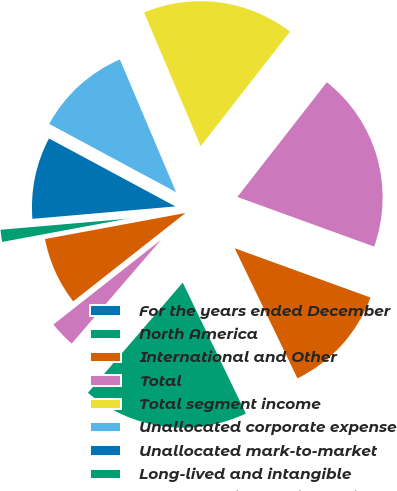<chart> <loc_0><loc_0><loc_500><loc_500><pie_chart><fcel>For the years ended December<fcel>North America<fcel>International and Other<fcel>Total<fcel>Total segment income<fcel>Unallocated corporate expense<fcel>Unallocated mark-to-market<fcel>Long-lived and intangible<fcel>Costs associated with business<fcel>Acquisition-related costs<nl><fcel>0.0%<fcel>18.46%<fcel>12.31%<fcel>20.0%<fcel>16.92%<fcel>10.77%<fcel>9.23%<fcel>1.54%<fcel>7.69%<fcel>3.08%<nl></chart> 